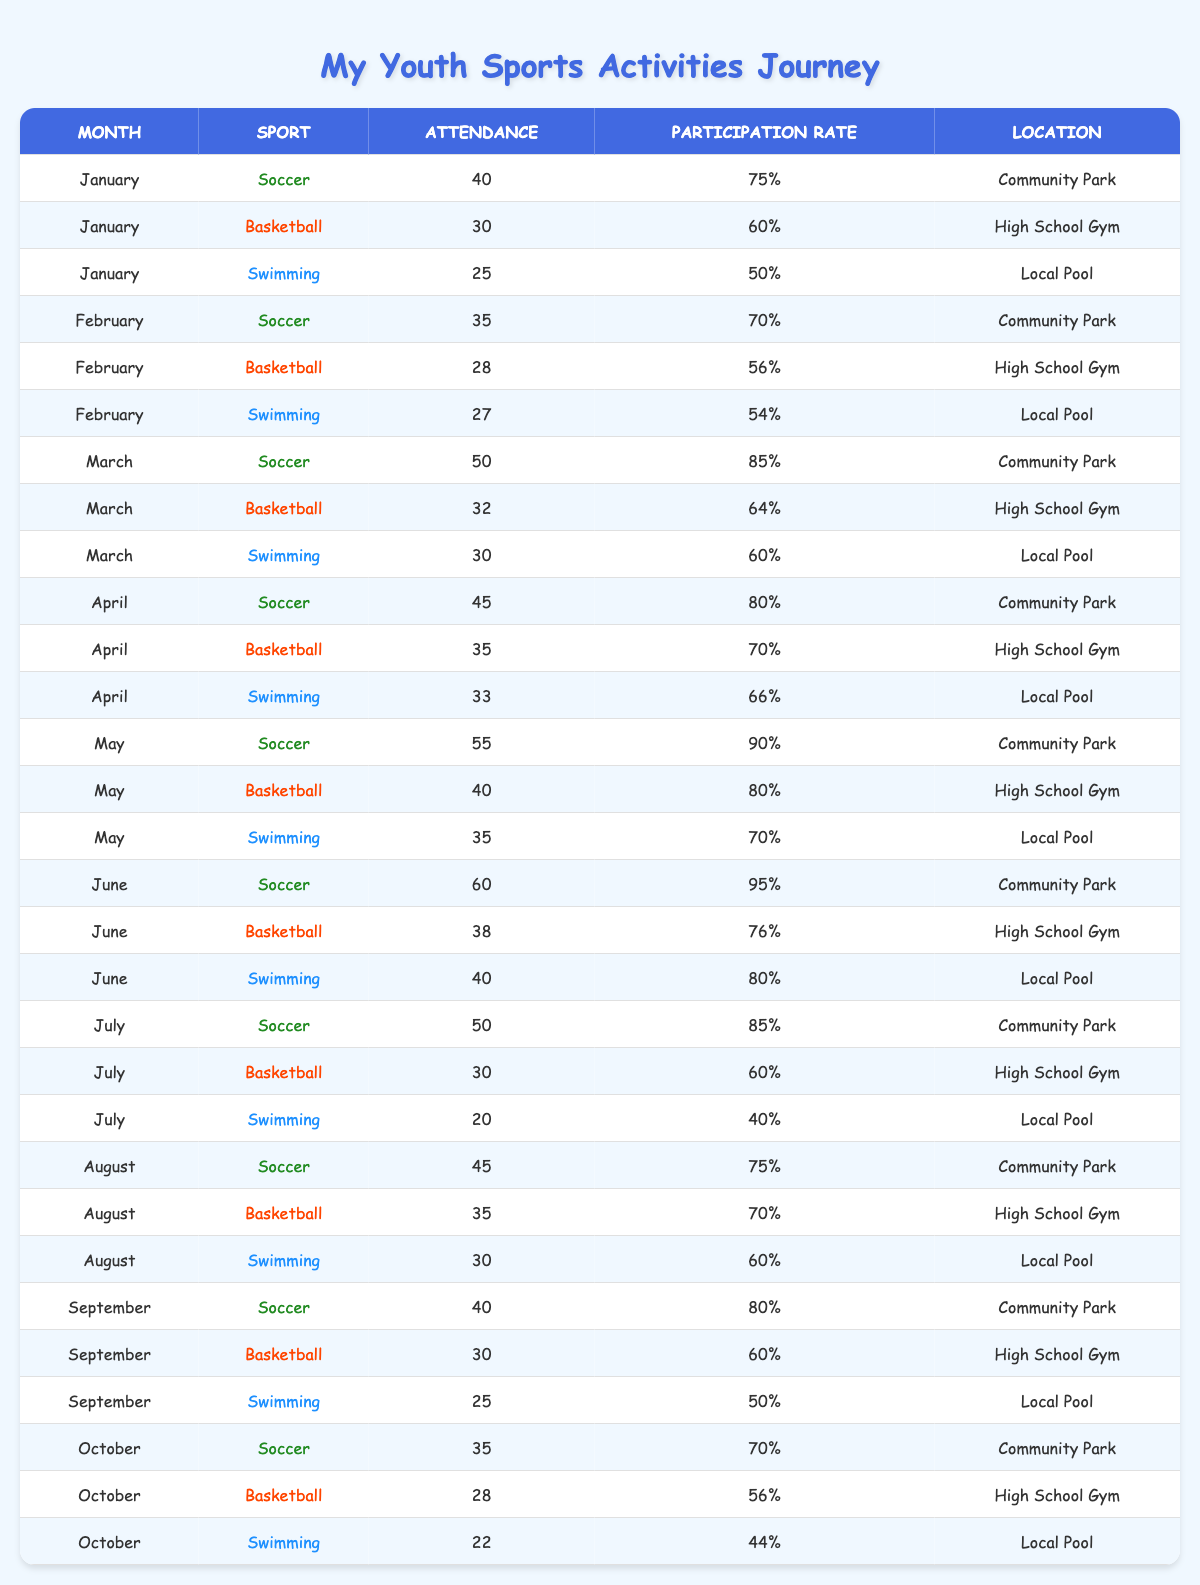What sport had the highest attendance in June? In June, Soccer had an attendance of 60, which is higher than Basketball's 38 and Swimming's 40
Answer: Soccer What was the overall participation rate for Soccer in the months from January to April? The participation rates for Soccer from January (75%), February (70%), March (85%), and April (80%) add up to 310%. There are 4 months, so the average is 310% / 4 = 77.5%
Answer: 77.5% Did participation in Swimming ever exceed 80%? The highest participation rate for Swimming was 80% in June, but it never exceeded
Answer: No Which month had the lowest attendance for Basketball? In February, Basketball had an attendance of 28, which is lower than any other month for this sport
Answer: February What is the average attendance for Soccer throughout the year? The attendance values for Soccer from January to October are 40, 35, 50, 45, 55, 60, 50, 45, 40, and 35. The total attendance is 455 and the average is 455 / 10 = 45.5
Answer: 45.5 Which sport had the highest participation rate in July? For July, Soccer had a participation rate of 85%, while Basketball had 60% and Swimming had 40%, making Soccer the highest for July
Answer: Soccer In which month did participation in Swimming reach its lowest? In July, Swimming had a participation rate of 40%, which is the lowest of the year for this sport
Answer: July What was the combined attendance for Basketball in the first half of the year? The attendance for Basketball from January to June is 30 + 28 + 32 + 35 + 40 + 38 = 203
Answer: 203 How many months had a participation rate of 70% or higher for Swimming? The participation rates for Swimming that were 70% or higher occurred in May (70%) and June (80%), totaling 2 months
Answer: 2 What is the difference in attendance between the highest and lowest month for Soccer? The highest attendance for Soccer was 60 in June, and the lowest was 35 in February. The difference is 60 - 35 = 25
Answer: 25 Was there ever a month where Soccer and Swimming had the same attendance? In September, Soccer had 40 and Swimming had 25, so they never had the same attendance in any month
Answer: No 